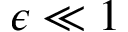Convert formula to latex. <formula><loc_0><loc_0><loc_500><loc_500>{ \epsilon \ll 1 }</formula> 